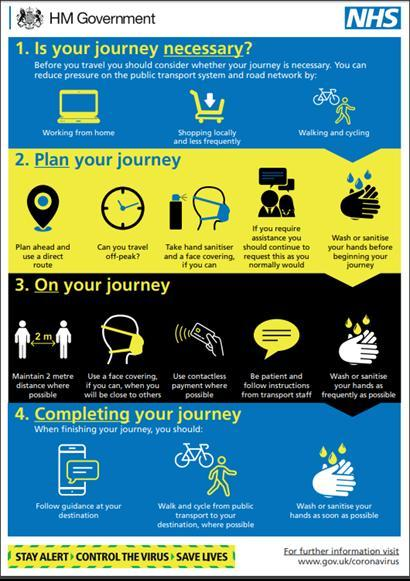what distance should be maintained ?
Answer the question with a short phrase. 2 metre What should you carry when you plan to make a journey? hand sanitiser and a face covering Which method of payment is preferable? contactless payment what should be done as frequently as possible when travelling? wash or sanitise your hands what should you do before beginning your journey? wash or sanitise your hands Which alternate modes of travel can be used instead of public transport? walking and cycling Which time is better to travel - during peak hour or off-peak? off-peak 